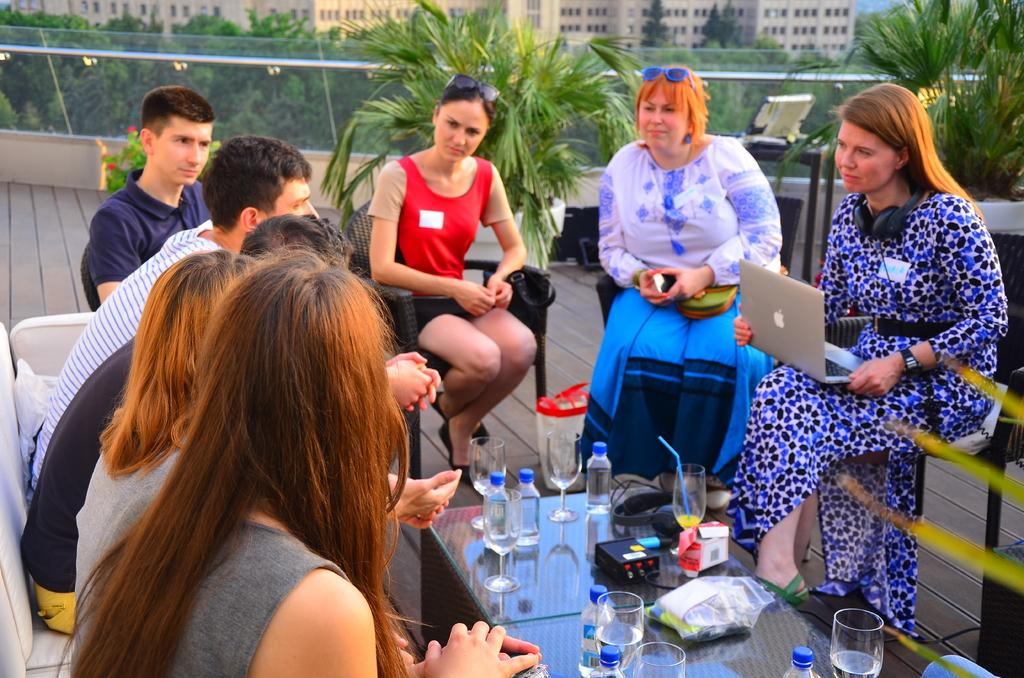What are the people in the image doing? The people in the image are sitting on chairs. What is the primary piece of furniture in the image? There is a table in the image. What can be seen on the table? There are objects placed on the table. What type of air can be seen flowing around the people in the image? There is no airflow visible in the image; it is a still image. Can you describe the crow that is perched on the table in the image? There is no crow present in the image; only people, chairs, and objects on the table are visible. 